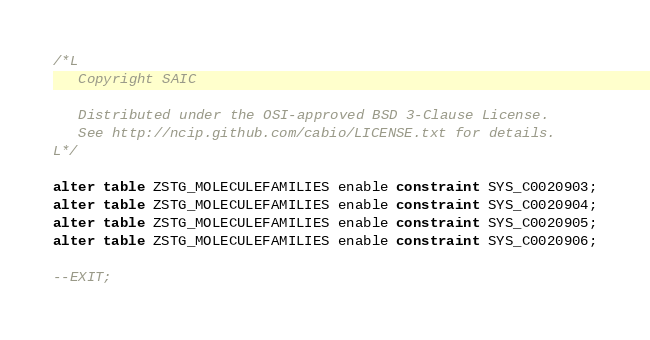<code> <loc_0><loc_0><loc_500><loc_500><_SQL_>/*L
   Copyright SAIC

   Distributed under the OSI-approved BSD 3-Clause License.
   See http://ncip.github.com/cabio/LICENSE.txt for details.
L*/

alter table ZSTG_MOLECULEFAMILIES enable constraint SYS_C0020903;
alter table ZSTG_MOLECULEFAMILIES enable constraint SYS_C0020904;
alter table ZSTG_MOLECULEFAMILIES enable constraint SYS_C0020905;
alter table ZSTG_MOLECULEFAMILIES enable constraint SYS_C0020906;

--EXIT;
</code> 